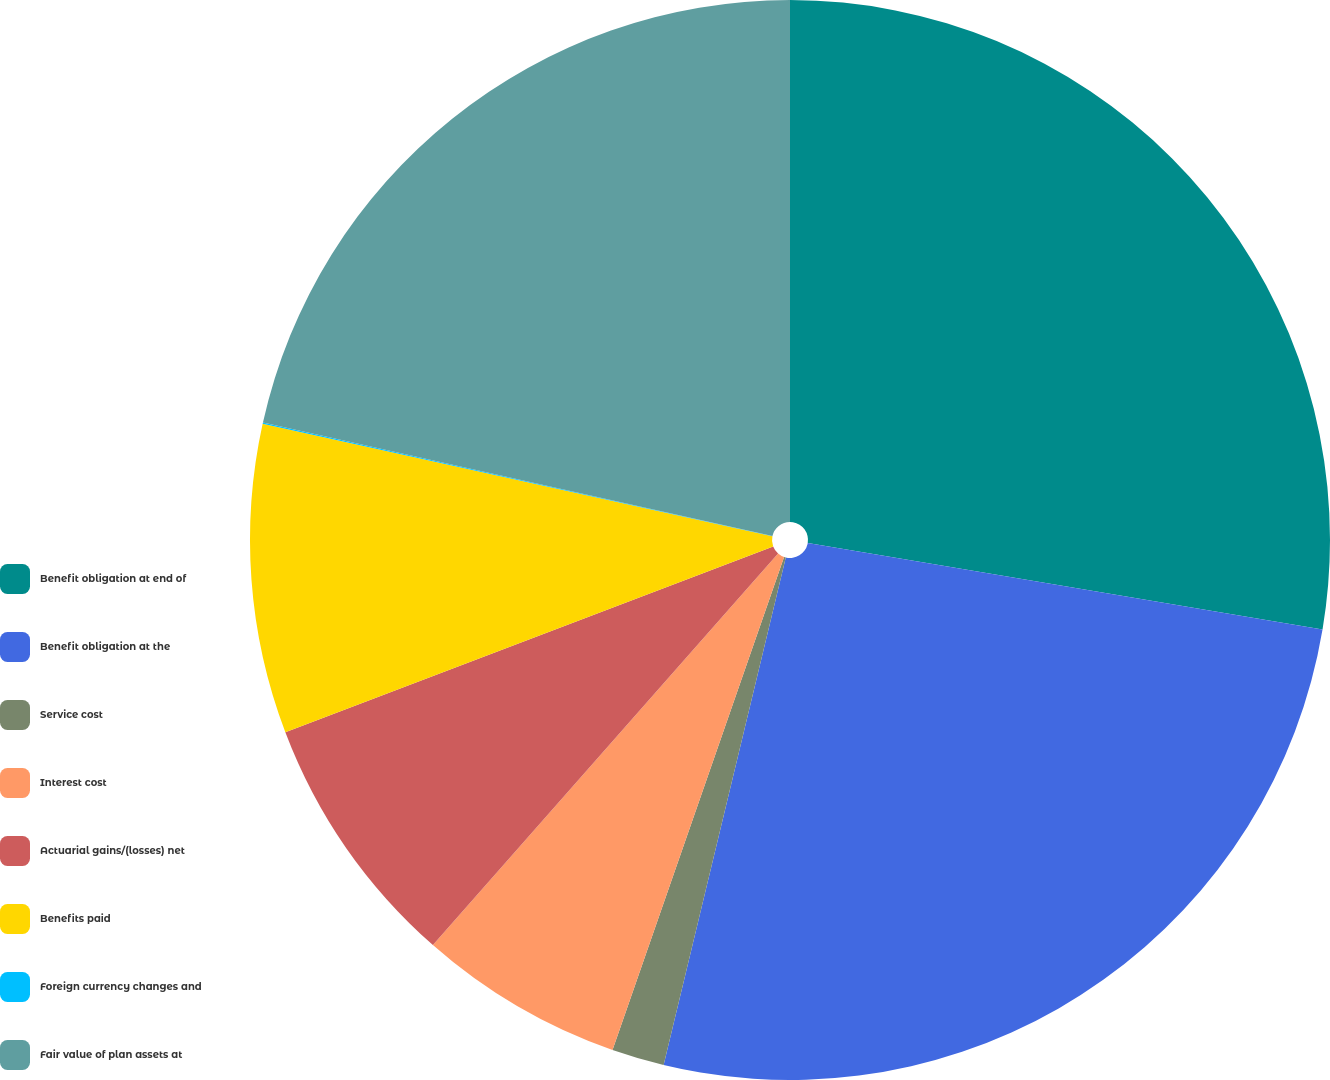<chart> <loc_0><loc_0><loc_500><loc_500><pie_chart><fcel>Benefit obligation at end of<fcel>Benefit obligation at the<fcel>Service cost<fcel>Interest cost<fcel>Actuarial gains/(losses) net<fcel>Benefits paid<fcel>Foreign currency changes and<fcel>Fair value of plan assets at<nl><fcel>27.65%<fcel>26.11%<fcel>1.57%<fcel>6.17%<fcel>7.71%<fcel>9.24%<fcel>0.04%<fcel>21.51%<nl></chart> 